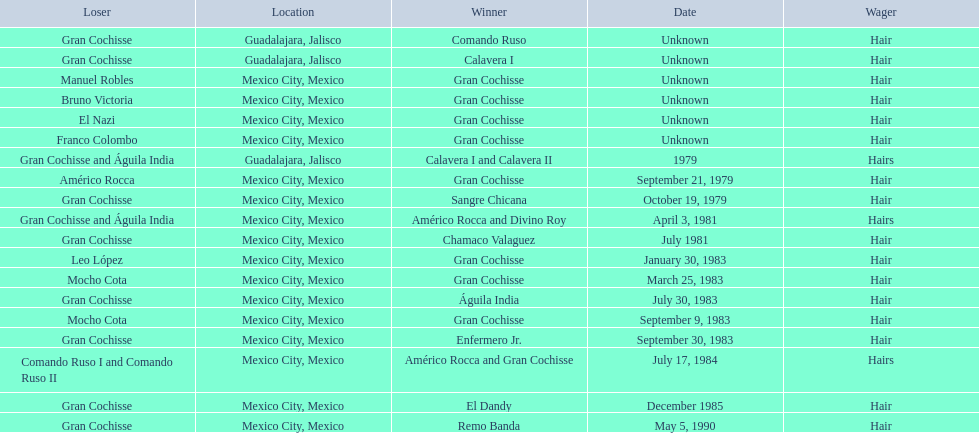When did bruno victoria lose his first game? Unknown. 